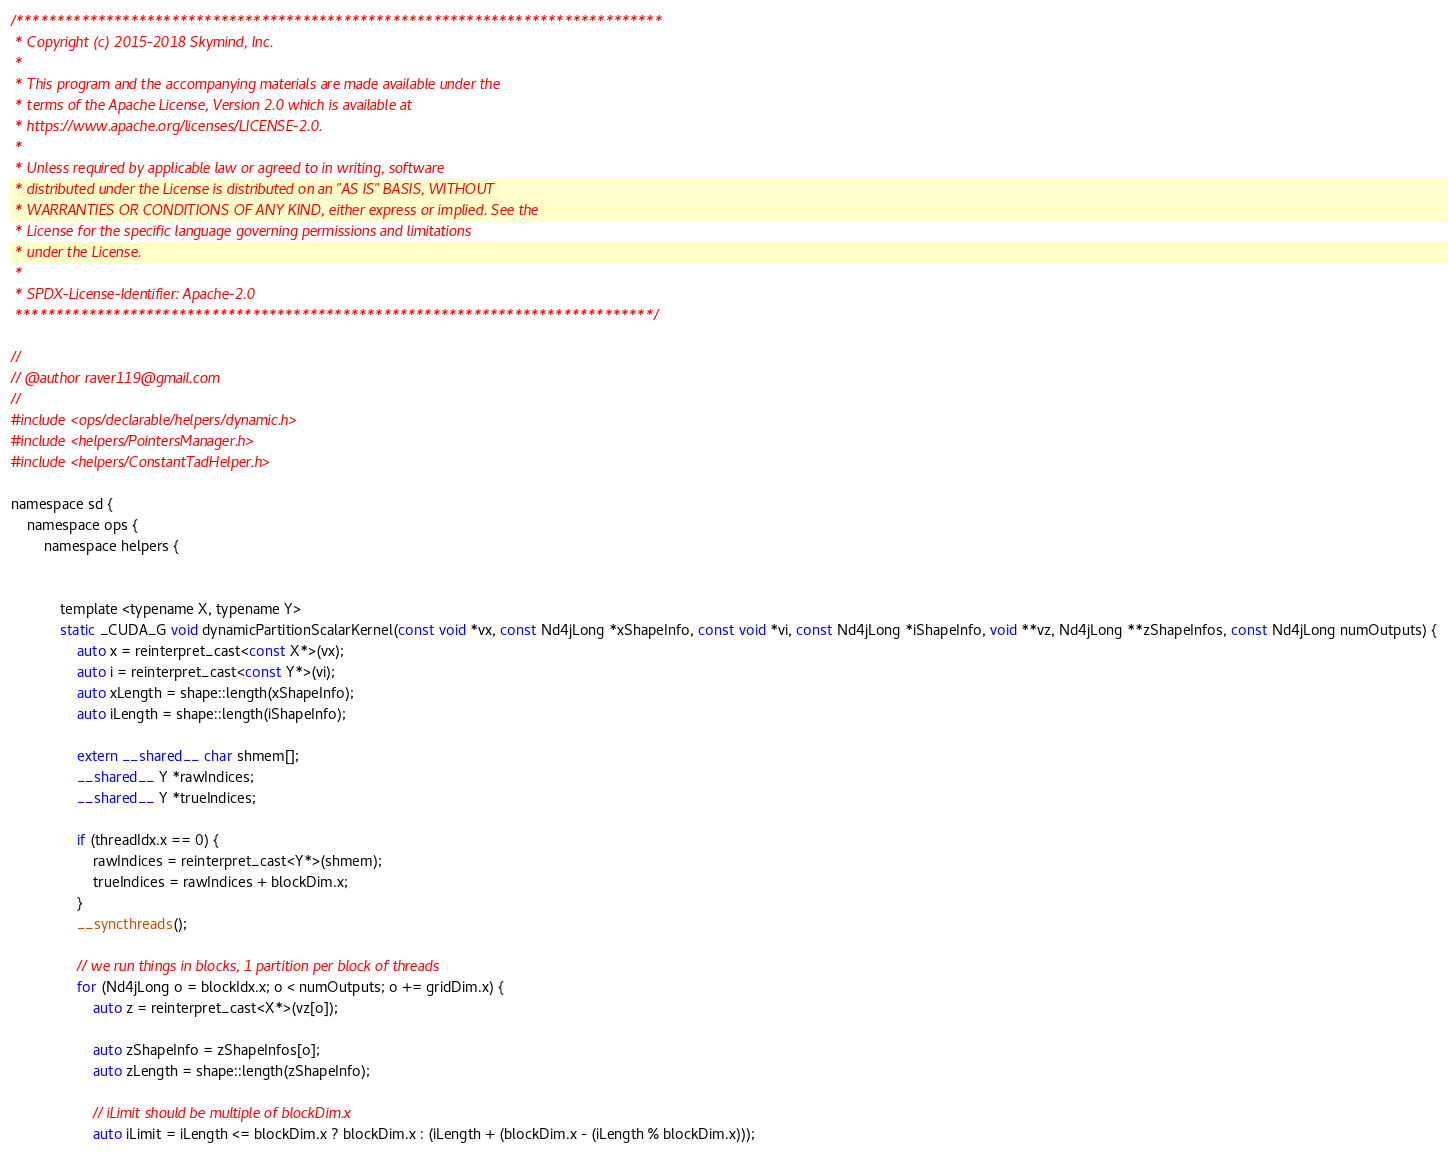<code> <loc_0><loc_0><loc_500><loc_500><_Cuda_>/*******************************************************************************
 * Copyright (c) 2015-2018 Skymind, Inc.
 *
 * This program and the accompanying materials are made available under the
 * terms of the Apache License, Version 2.0 which is available at
 * https://www.apache.org/licenses/LICENSE-2.0.
 *
 * Unless required by applicable law or agreed to in writing, software
 * distributed under the License is distributed on an "AS IS" BASIS, WITHOUT
 * WARRANTIES OR CONDITIONS OF ANY KIND, either express or implied. See the
 * License for the specific language governing permissions and limitations
 * under the License.
 *
 * SPDX-License-Identifier: Apache-2.0
 ******************************************************************************/

//
// @author raver119@gmail.com
//
#include <ops/declarable/helpers/dynamic.h>
#include <helpers/PointersManager.h>
#include <helpers/ConstantTadHelper.h>

namespace sd {
    namespace ops {
        namespace helpers {


            template <typename X, typename Y>
            static _CUDA_G void dynamicPartitionScalarKernel(const void *vx, const Nd4jLong *xShapeInfo, const void *vi, const Nd4jLong *iShapeInfo, void **vz, Nd4jLong **zShapeInfos, const Nd4jLong numOutputs) {
                auto x = reinterpret_cast<const X*>(vx);
                auto i = reinterpret_cast<const Y*>(vi);
                auto xLength = shape::length(xShapeInfo);
                auto iLength = shape::length(iShapeInfo);

                extern __shared__ char shmem[];
                __shared__ Y *rawIndices;
                __shared__ Y *trueIndices;

                if (threadIdx.x == 0) {
                    rawIndices = reinterpret_cast<Y*>(shmem);
                    trueIndices = rawIndices + blockDim.x;
                }
                __syncthreads();

                // we run things in blocks, 1 partition per block of threads
                for (Nd4jLong o = blockIdx.x; o < numOutputs; o += gridDim.x) {
                    auto z = reinterpret_cast<X*>(vz[o]);

                    auto zShapeInfo = zShapeInfos[o];
                    auto zLength = shape::length(zShapeInfo);

                    // iLimit should be multiple of blockDim.x
                    auto iLimit = iLength <= blockDim.x ? blockDim.x : (iLength + (blockDim.x - (iLength % blockDim.x)));</code> 